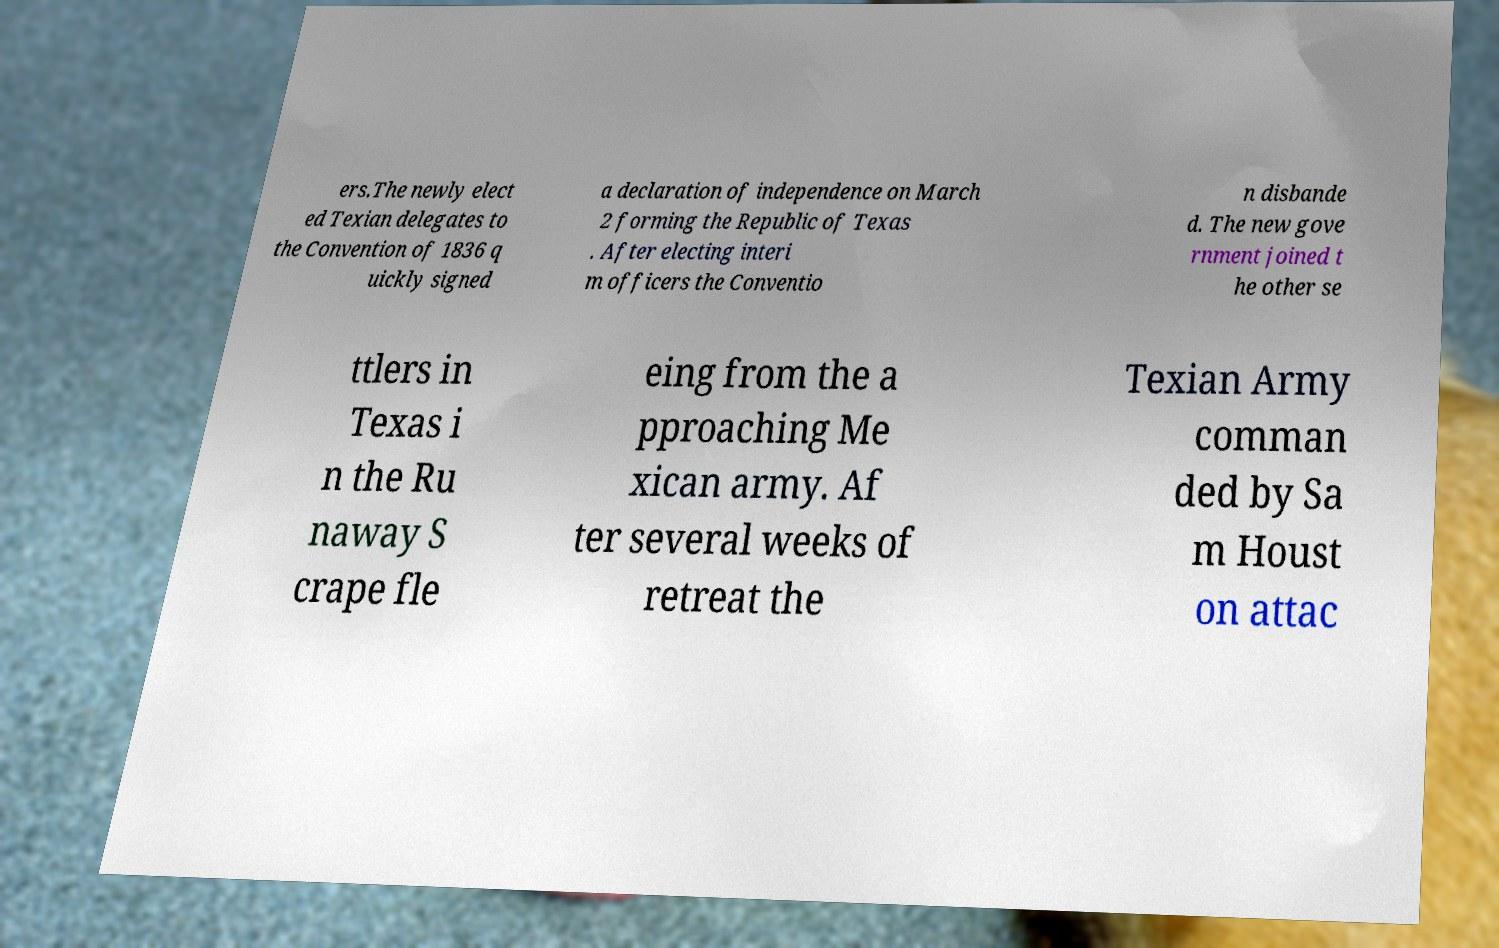Could you assist in decoding the text presented in this image and type it out clearly? ers.The newly elect ed Texian delegates to the Convention of 1836 q uickly signed a declaration of independence on March 2 forming the Republic of Texas . After electing interi m officers the Conventio n disbande d. The new gove rnment joined t he other se ttlers in Texas i n the Ru naway S crape fle eing from the a pproaching Me xican army. Af ter several weeks of retreat the Texian Army comman ded by Sa m Houst on attac 